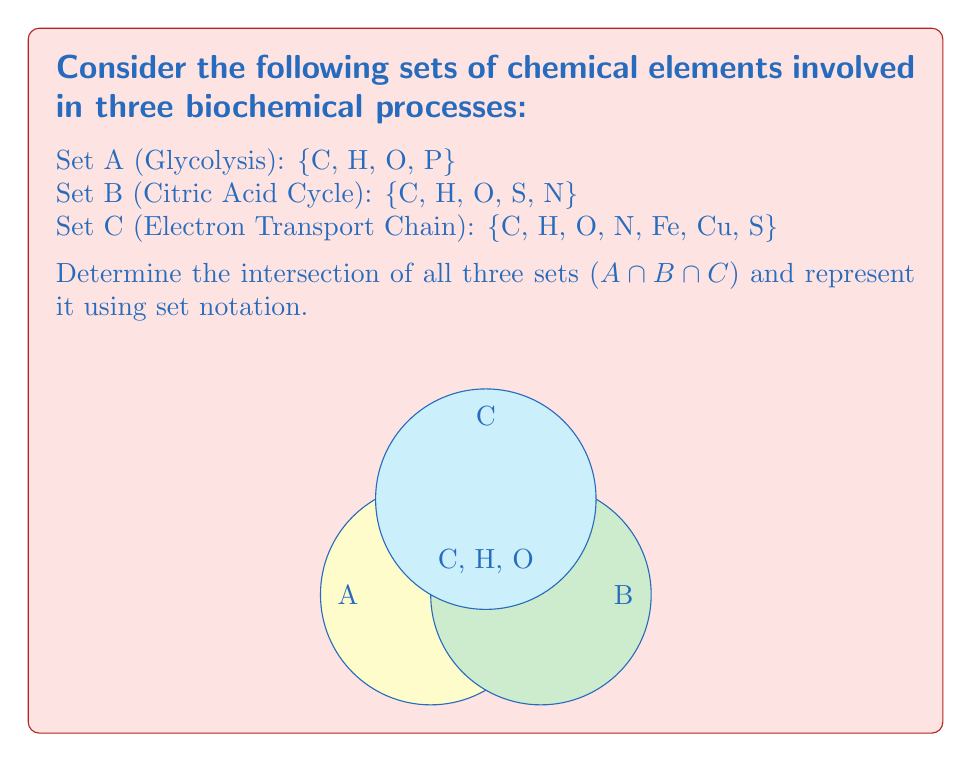Give your solution to this math problem. To find the intersection of sets A, B, and C, we need to identify the elements that are common to all three sets. Let's approach this step-by-step:

1. First, let's list out the elements in each set:
   Set A: {C, H, O, P}
   Set B: {C, H, O, S, N}
   Set C: {C, H, O, N, Fe, Cu, S}

2. Now, we need to identify which elements appear in all three sets:
   - C (Carbon) appears in all three sets
   - H (Hydrogen) appears in all three sets
   - O (Oxygen) appears in all three sets

3. Other elements like P, S, N, Fe, and Cu do not appear in all three sets, so they are not part of the intersection.

4. The intersection of sets A, B, and C, denoted as A ∩ B ∩ C, contains only the elements that are present in all three sets.

5. Therefore, the intersection A ∩ B ∩ C = {C, H, O}

6. In set notation, we write this as:
   $$A \cap B \cap C = \{C, H, O\}$$

This result shows that Carbon, Hydrogen, and Oxygen are common to all three biochemical processes (Glycolysis, Citric Acid Cycle, and Electron Transport Chain), which aligns with their fundamental importance in biochemistry.
Answer: $$A \cap B \cap C = \{C, H, O\}$$ 